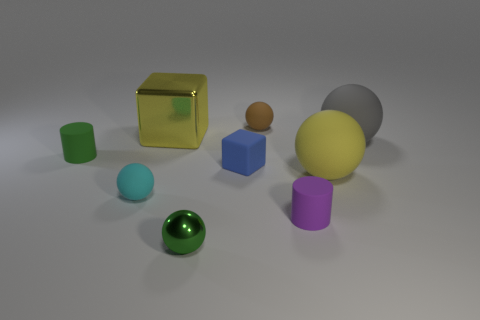What shape is the thing that is the same color as the large block?
Your answer should be compact. Sphere. What is the color of the rubber cylinder that is in front of the tiny blue block in front of the tiny matte sphere that is behind the blue rubber block?
Your response must be concise. Purple. There is a metal thing that is the same size as the blue rubber block; what color is it?
Ensure brevity in your answer.  Green. There is a big metal thing; is it the same color as the tiny rubber object behind the yellow shiny cube?
Your answer should be very brief. No. What is the cylinder that is in front of the yellow thing that is on the right side of the purple cylinder made of?
Keep it short and to the point. Rubber. What number of metallic things are both behind the tiny green rubber object and in front of the cyan rubber thing?
Give a very brief answer. 0. What number of other objects are the same size as the brown matte thing?
Offer a terse response. 5. There is a tiny green thing that is in front of the big yellow matte ball; is it the same shape as the yellow thing that is behind the yellow sphere?
Your answer should be very brief. No. Are there any yellow metal things on the left side of the metal block?
Ensure brevity in your answer.  No. What is the color of the other small metal thing that is the same shape as the gray object?
Your answer should be compact. Green. 